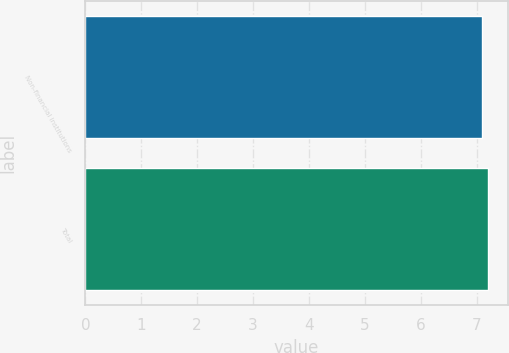Convert chart. <chart><loc_0><loc_0><loc_500><loc_500><bar_chart><fcel>Non-financial institutions<fcel>Total<nl><fcel>7.1<fcel>7.2<nl></chart> 